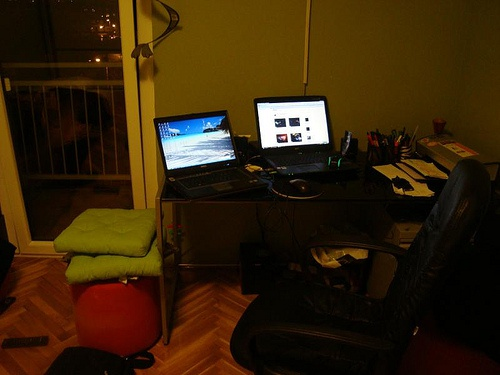Describe the objects in this image and their specific colors. I can see chair in black, maroon, and olive tones, laptop in black and lightblue tones, laptop in black, white, navy, and darkgray tones, handbag in maroon, black, and gray tones, and backpack in maroon, black, and gray tones in this image. 